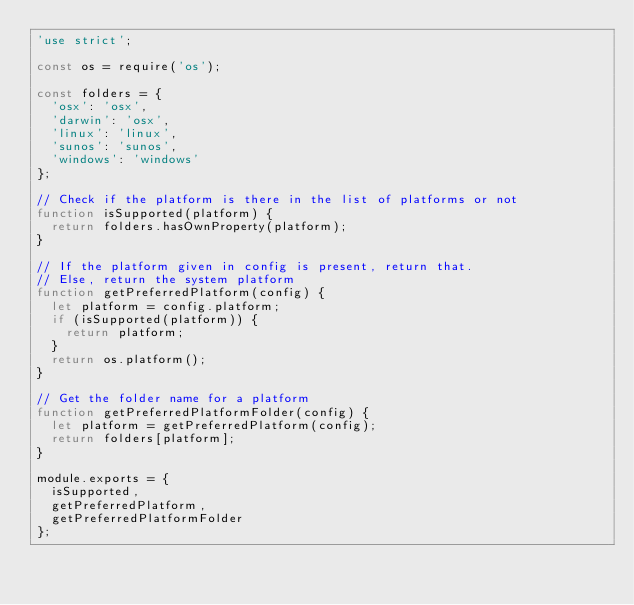Convert code to text. <code><loc_0><loc_0><loc_500><loc_500><_JavaScript_>'use strict';

const os = require('os');

const folders = {
  'osx': 'osx',
  'darwin': 'osx',
  'linux': 'linux',
  'sunos': 'sunos',
  'windows': 'windows'
};

// Check if the platform is there in the list of platforms or not
function isSupported(platform) {
  return folders.hasOwnProperty(platform);
}

// If the platform given in config is present, return that.
// Else, return the system platform
function getPreferredPlatform(config) {
  let platform = config.platform;
  if (isSupported(platform)) {
    return platform;
  }
  return os.platform();
}

// Get the folder name for a platform
function getPreferredPlatformFolder(config) {
  let platform = getPreferredPlatform(config);
  return folders[platform];
}

module.exports = {
  isSupported,
  getPreferredPlatform,
  getPreferredPlatformFolder
};
</code> 